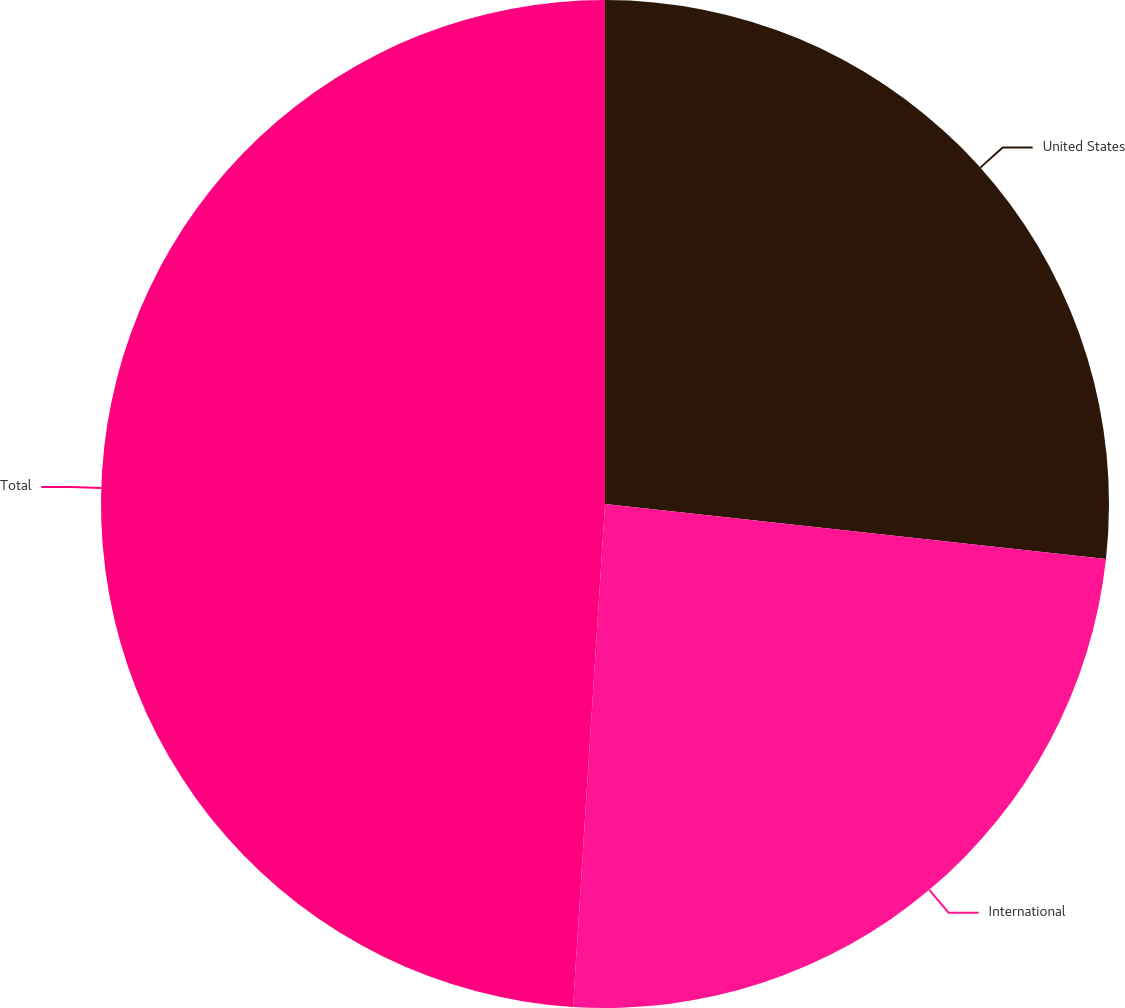Convert chart. <chart><loc_0><loc_0><loc_500><loc_500><pie_chart><fcel>United States<fcel>International<fcel>Total<nl><fcel>26.74%<fcel>24.27%<fcel>48.99%<nl></chart> 